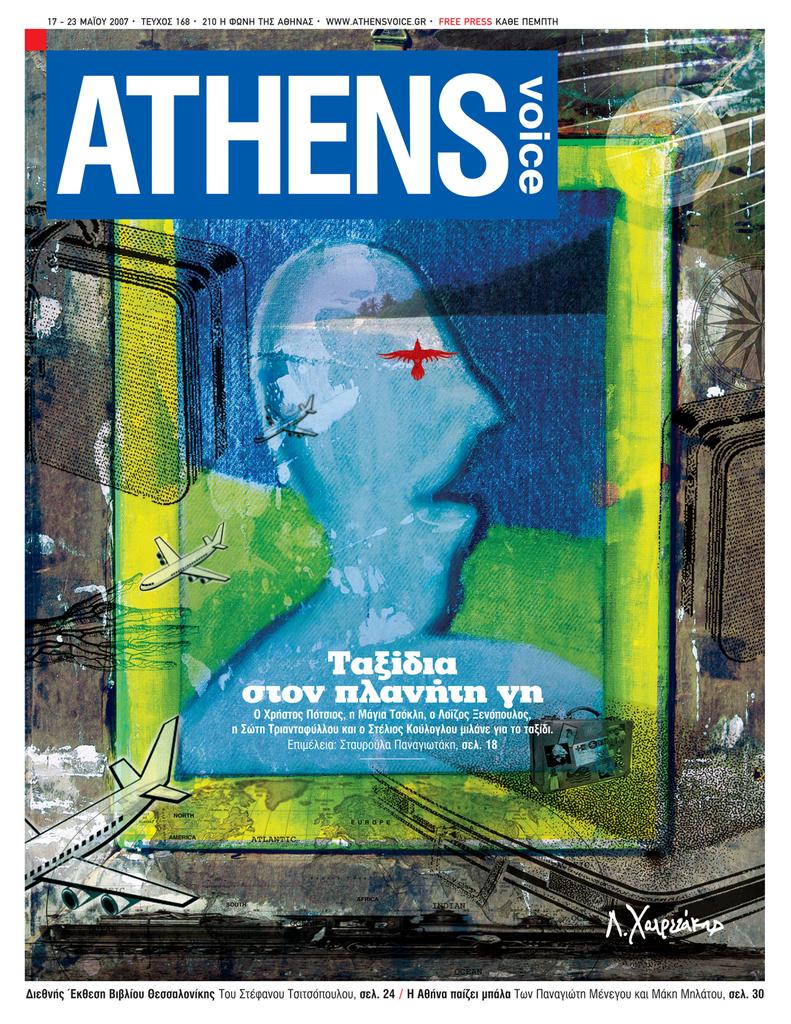What are the english words in the box?
Provide a short and direct response. Athens voice. What year was this published?
Offer a terse response. 2007. 